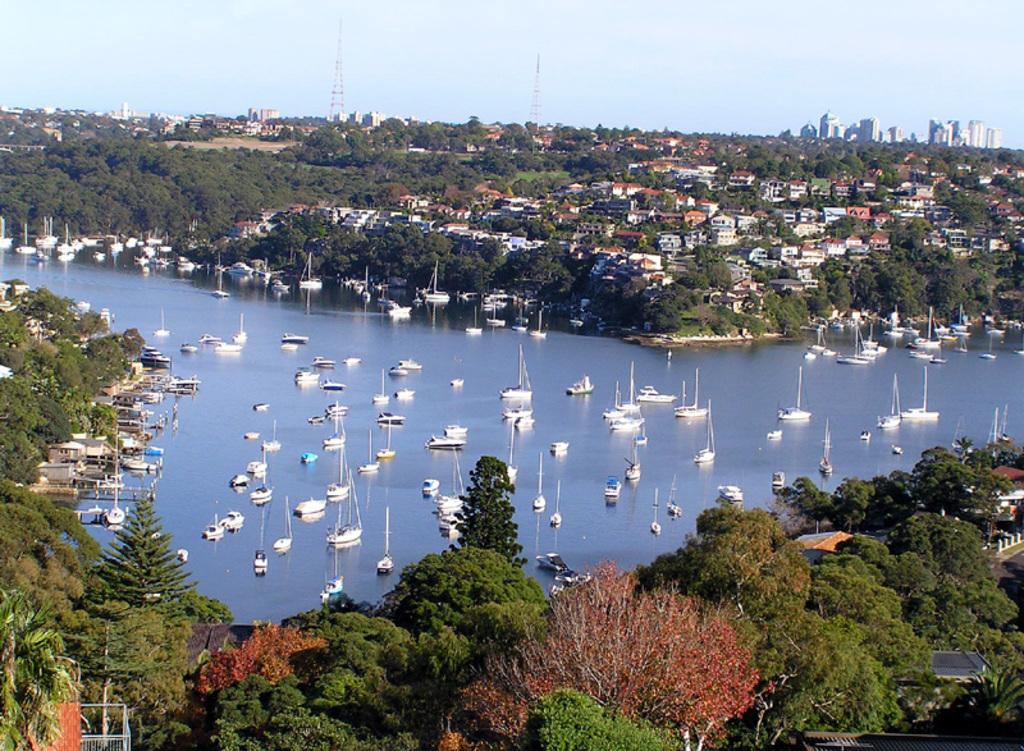Describe this image in one or two sentences. In this image I can see few trees which are green and orange in color, few buildings, the water and few boats on the surface of the water. In the background I can see few buildings, few towers and the sky. 